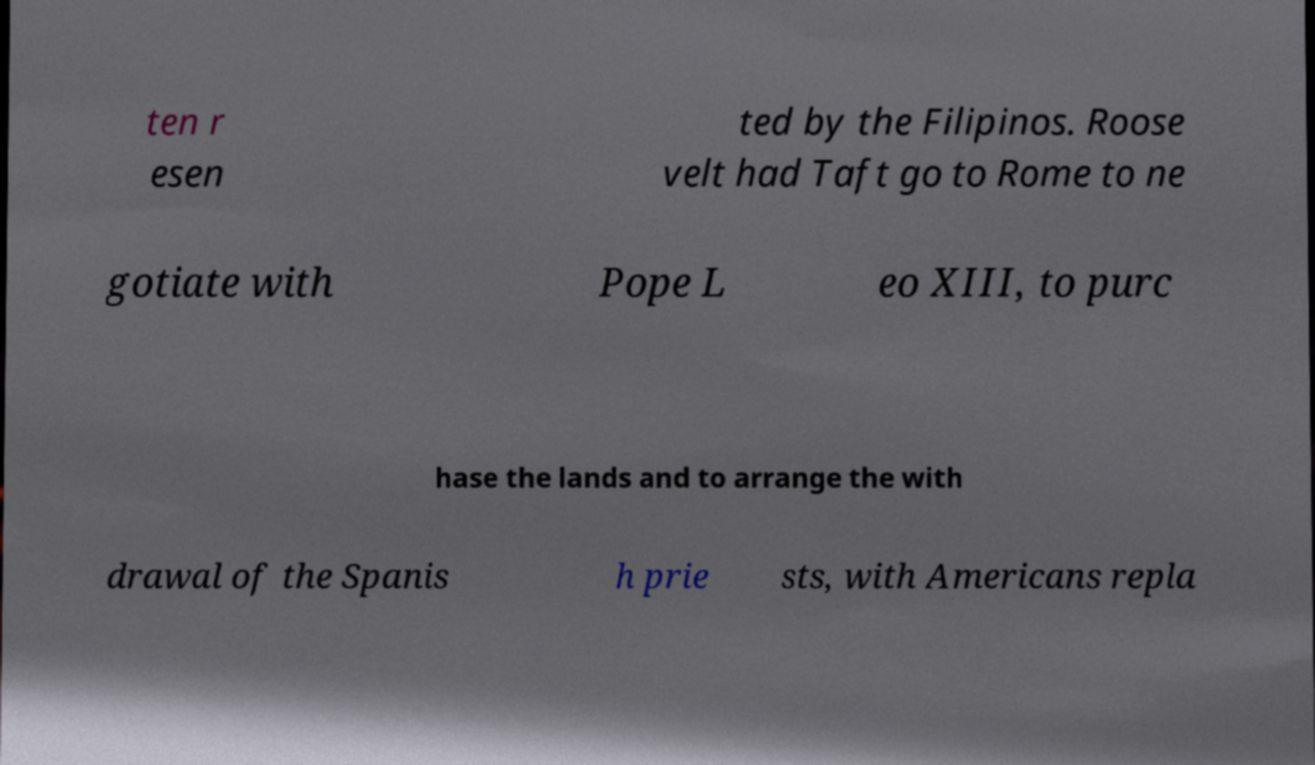Could you assist in decoding the text presented in this image and type it out clearly? ten r esen ted by the Filipinos. Roose velt had Taft go to Rome to ne gotiate with Pope L eo XIII, to purc hase the lands and to arrange the with drawal of the Spanis h prie sts, with Americans repla 